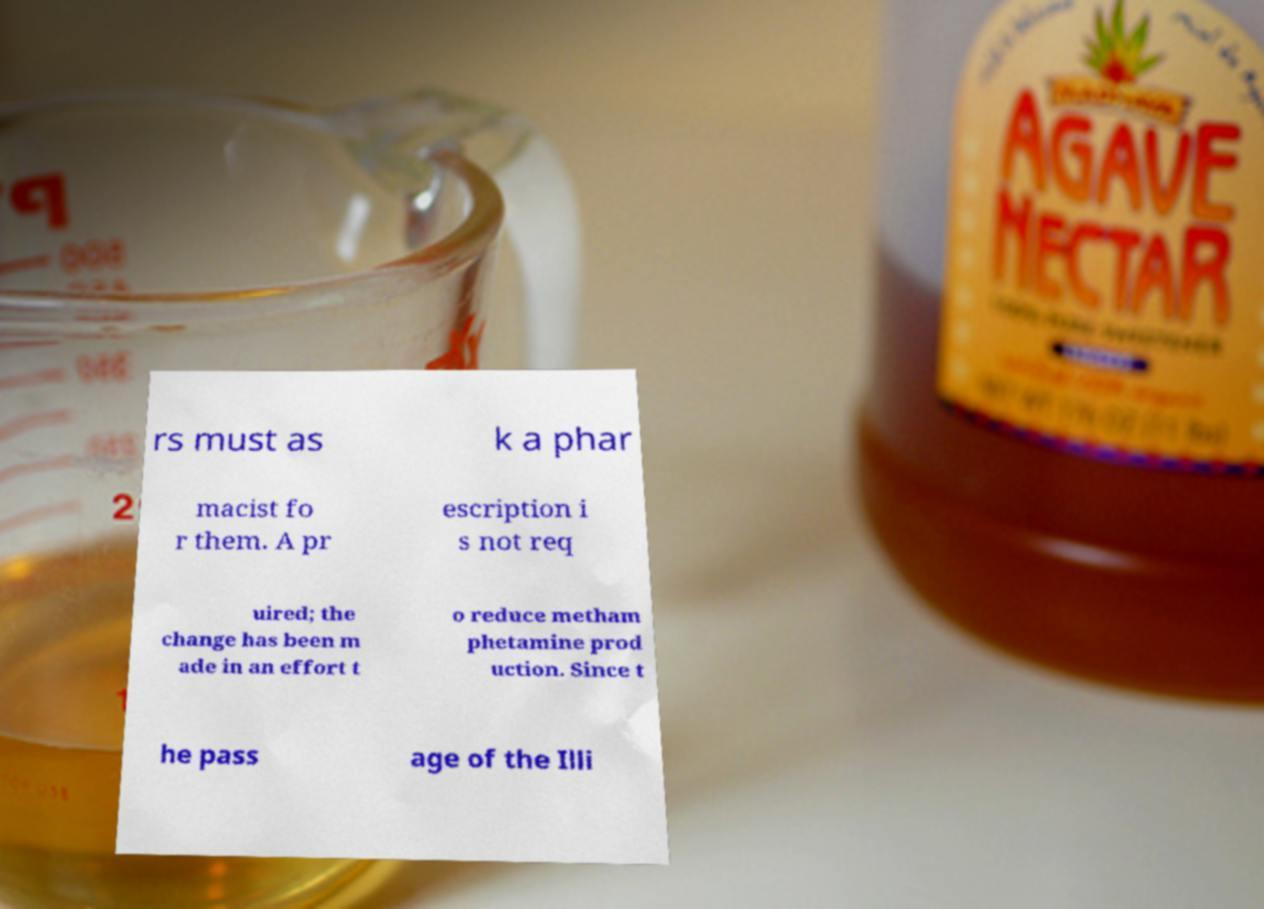For documentation purposes, I need the text within this image transcribed. Could you provide that? rs must as k a phar macist fo r them. A pr escription i s not req uired; the change has been m ade in an effort t o reduce metham phetamine prod uction. Since t he pass age of the Illi 